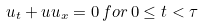Convert formula to latex. <formula><loc_0><loc_0><loc_500><loc_500>u _ { t } + u u _ { x } = 0 \, f o r \, 0 \leq t < \tau</formula> 